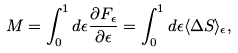Convert formula to latex. <formula><loc_0><loc_0><loc_500><loc_500>M = \int _ { 0 } ^ { 1 } d \epsilon \frac { \partial F _ { \epsilon } } { \partial \epsilon } = \int _ { 0 } ^ { 1 } d \epsilon \langle \Delta S \rangle _ { \epsilon } ,</formula> 